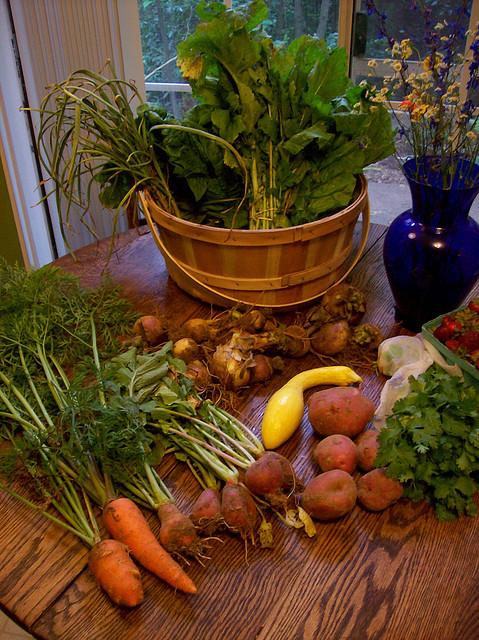What is in the vase?
Give a very brief answer. Flowers. How many squash?
Answer briefly. 1. How many carrots is for the soup?
Be succinct. 2. 